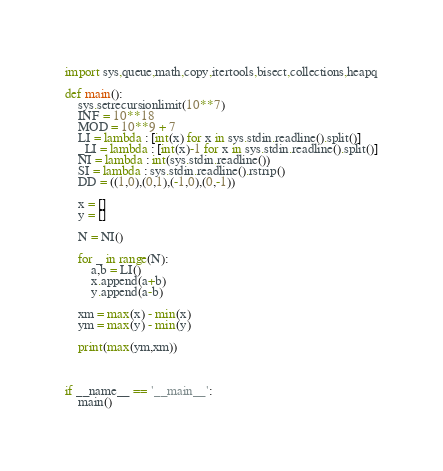<code> <loc_0><loc_0><loc_500><loc_500><_Python_>import sys,queue,math,copy,itertools,bisect,collections,heapq

def main():
    sys.setrecursionlimit(10**7)
    INF = 10**18
    MOD = 10**9 + 7
    LI = lambda : [int(x) for x in sys.stdin.readline().split()]
    _LI = lambda : [int(x)-1 for x in sys.stdin.readline().split()]
    NI = lambda : int(sys.stdin.readline())
    SI = lambda : sys.stdin.readline().rstrip()
    DD = ((1,0),(0,1),(-1,0),(0,-1))

    x = []
    y = []

    N = NI()

    for _ in range(N):
        a,b = LI()
        x.append(a+b)
        y.append(a-b)

    xm = max(x) - min(x)
    ym = max(y) - min(y)

    print(max(ym,xm))



if __name__ == '__main__':
    main()</code> 